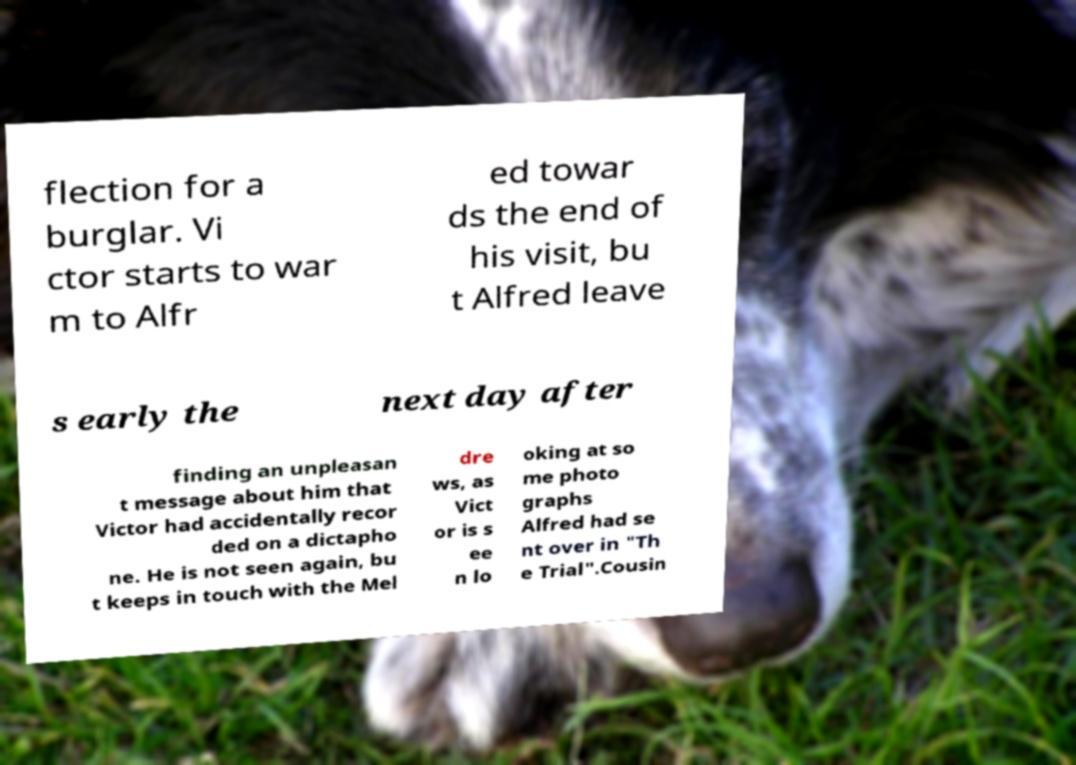What messages or text are displayed in this image? I need them in a readable, typed format. flection for a burglar. Vi ctor starts to war m to Alfr ed towar ds the end of his visit, bu t Alfred leave s early the next day after finding an unpleasan t message about him that Victor had accidentally recor ded on a dictapho ne. He is not seen again, bu t keeps in touch with the Mel dre ws, as Vict or is s ee n lo oking at so me photo graphs Alfred had se nt over in "Th e Trial".Cousin 